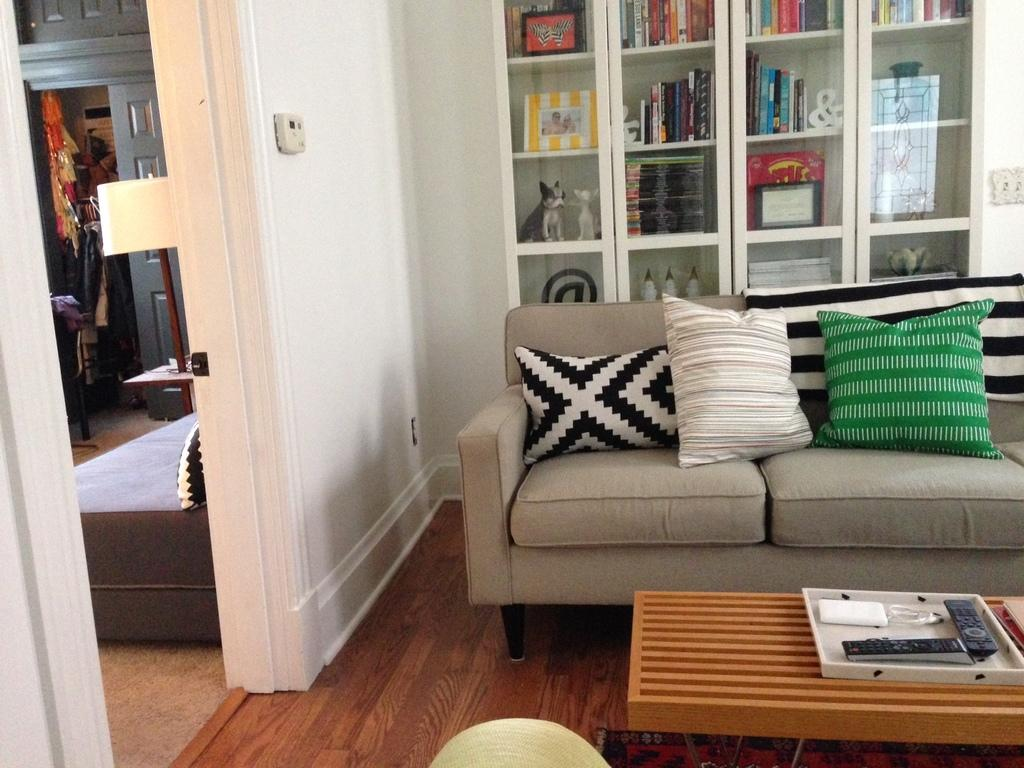What type of furniture is in the image? There is a sofa in the image. What is on the sofa? There are cushions on the sofa. What can be seen in the background of the image? There are books, frames, and toys in the background of the image. What objects are on the table in the image? There are two remotes and additional unspecified items on the table in the image. What type of veil is draped over the sofa in the image? There is no veil present in the image; it features a sofa with cushions and other items. How many steps can be seen leading up to the sofa in the image? There are no steps visible in the image; it only shows a sofa, cushions, and other items. 